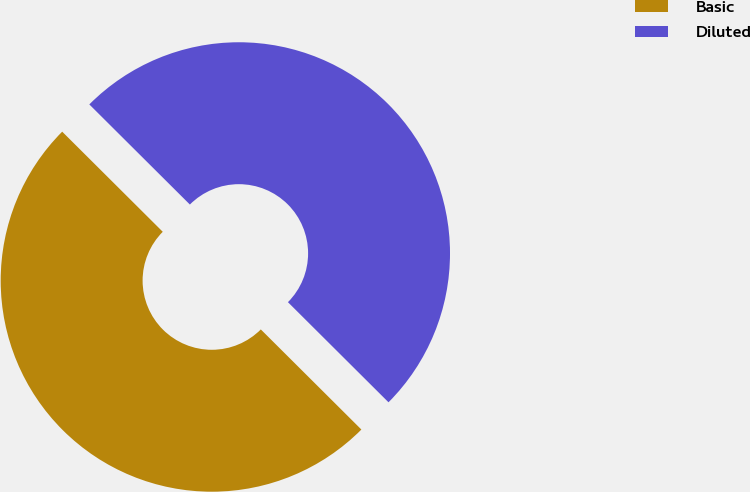Convert chart. <chart><loc_0><loc_0><loc_500><loc_500><pie_chart><fcel>Basic<fcel>Diluted<nl><fcel>50.0%<fcel>50.0%<nl></chart> 